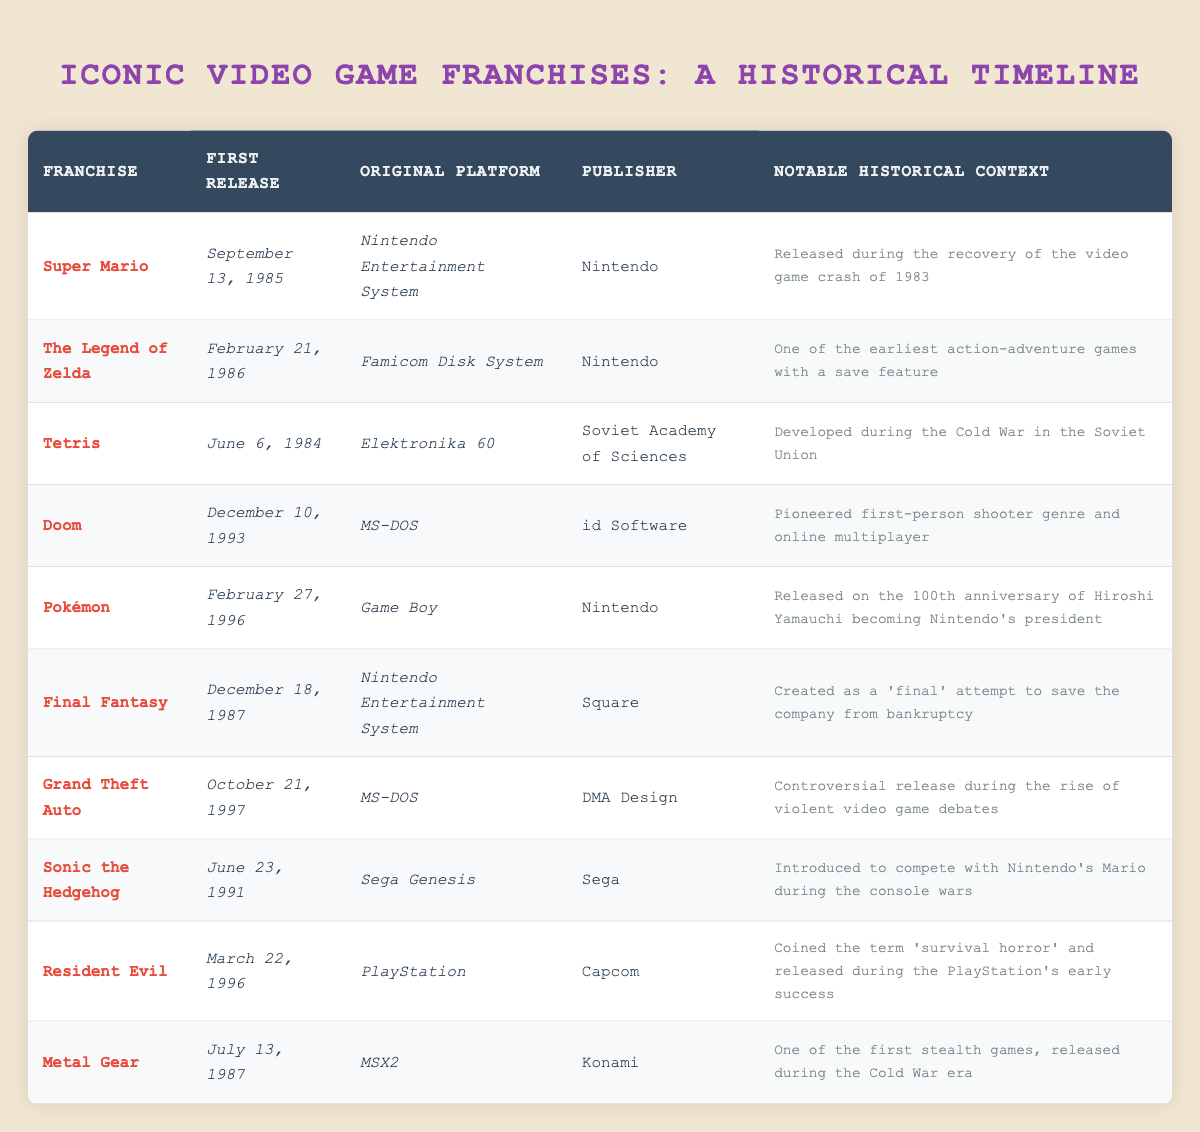What year was the first release of Tetris? The table shows that Tetris was first released on June 6, 1984. Therefore, the year is 1984.
Answer: 1984 Which publisher released the first Final Fantasy game? According to the table, Final Fantasy was published by Square.
Answer: Square Did the first release of Sonic the Hedgehog happen before or after the release of Doom? Sonic the Hedgehog was released on June 23, 1991, and Doom was released on December 10, 1993. Since June 1991 is earlier than December 1993, Sonic was released before Doom.
Answer: Before Which game was released on the 100th anniversary of Hiroshi Yamauchi becoming Nintendo's president? The table indicates that Pokémon, released on February 27, 1996, coincided with the 100th anniversary of Hiroshi Yamauchi’s presidency at Nintendo.
Answer: Pokémon What is the difference in years between the first release of Super Mario and The Legend of Zelda? Super Mario was first released in 1985 and The Legend of Zelda in 1986. The difference is 1986 - 1985 = 1 year.
Answer: 1 year How many games in the table were developed or published by Nintendo? The franchises Super Mario, The Legend of Zelda, and Pokémon were published by Nintendo, totaling three games.
Answer: 3 games Which franchise was released during the early success of the PlayStation and coined the term "survival horror"? Resident Evil, which was released on March 22, 1996, is identified in the table as the franchise that coined the term "survival horror" during the early success of the PlayStation.
Answer: Resident Evil Is Tetris the earliest release on the table? Tetris was first released on June 6, 1984. The other entries (Super Mario and The Legend of Zelda) were released in 1985 and 1986, respectively. Since no entries are before 1984, Tetris is the earliest.
Answer: Yes Which two franchises were originally released on MS-DOS? The table indicates that Doom and Grand Theft Auto were both released on MS-DOS.
Answer: Doom and Grand Theft Auto 